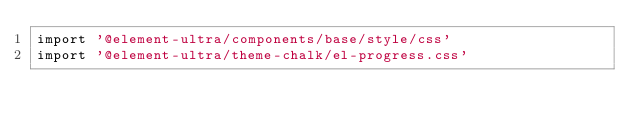Convert code to text. <code><loc_0><loc_0><loc_500><loc_500><_TypeScript_>import '@element-ultra/components/base/style/css'
import '@element-ultra/theme-chalk/el-progress.css'
</code> 